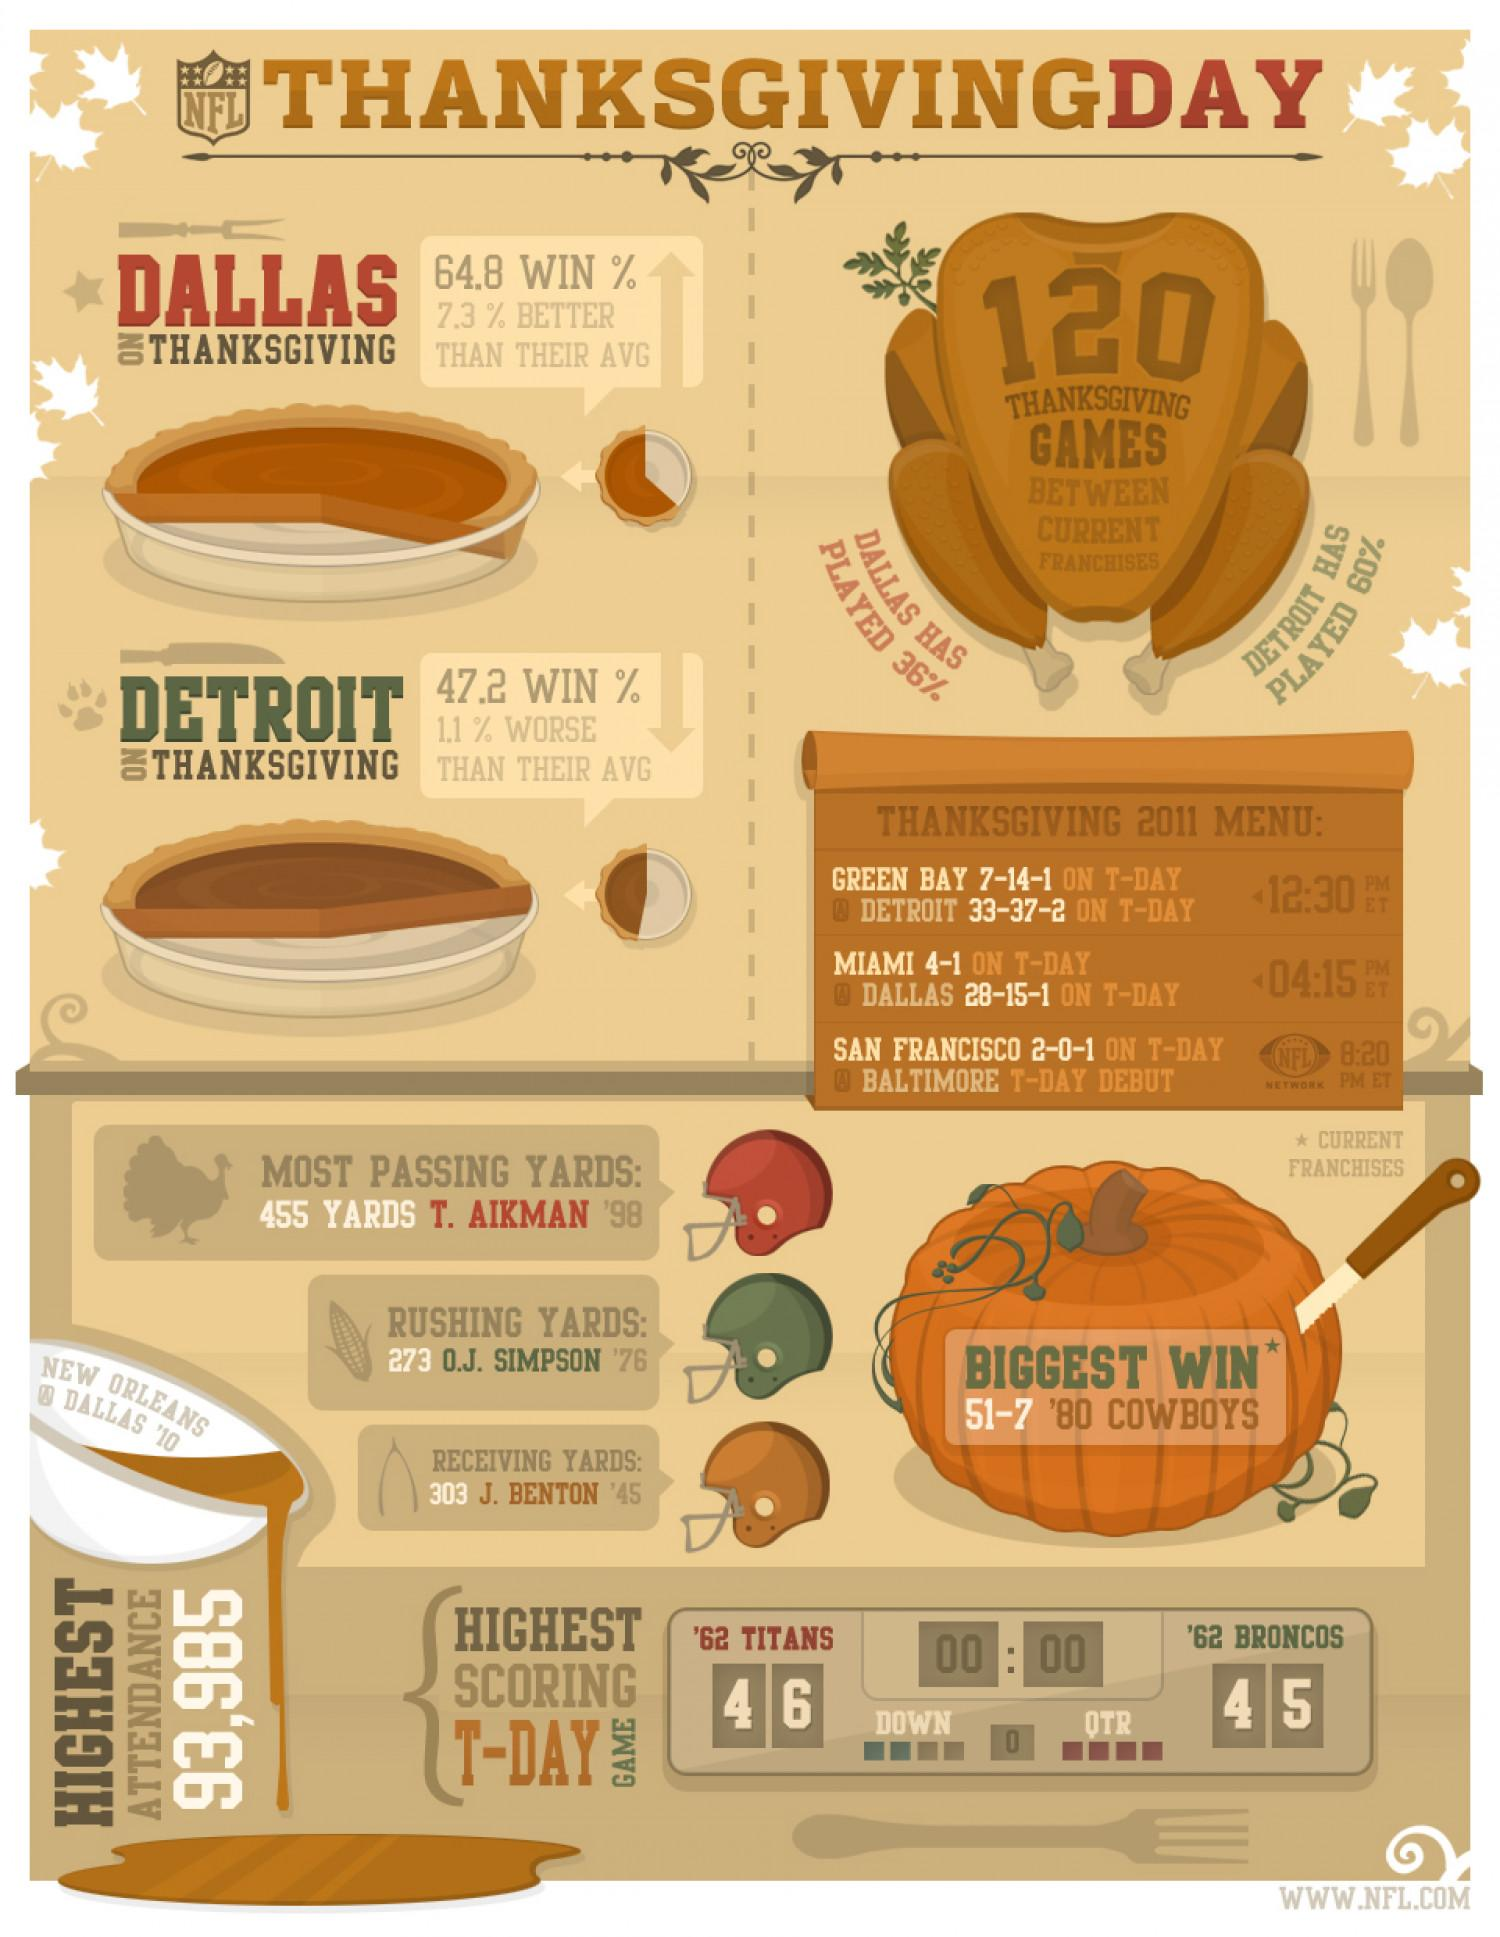Give some essential details in this illustration. Detroit has played more games than Dallas by 24%. Dallas has a significantly higher probability of winning the game on Thanksgiving compared to Detroit. 